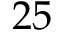Convert formula to latex. <formula><loc_0><loc_0><loc_500><loc_500>2 5</formula> 